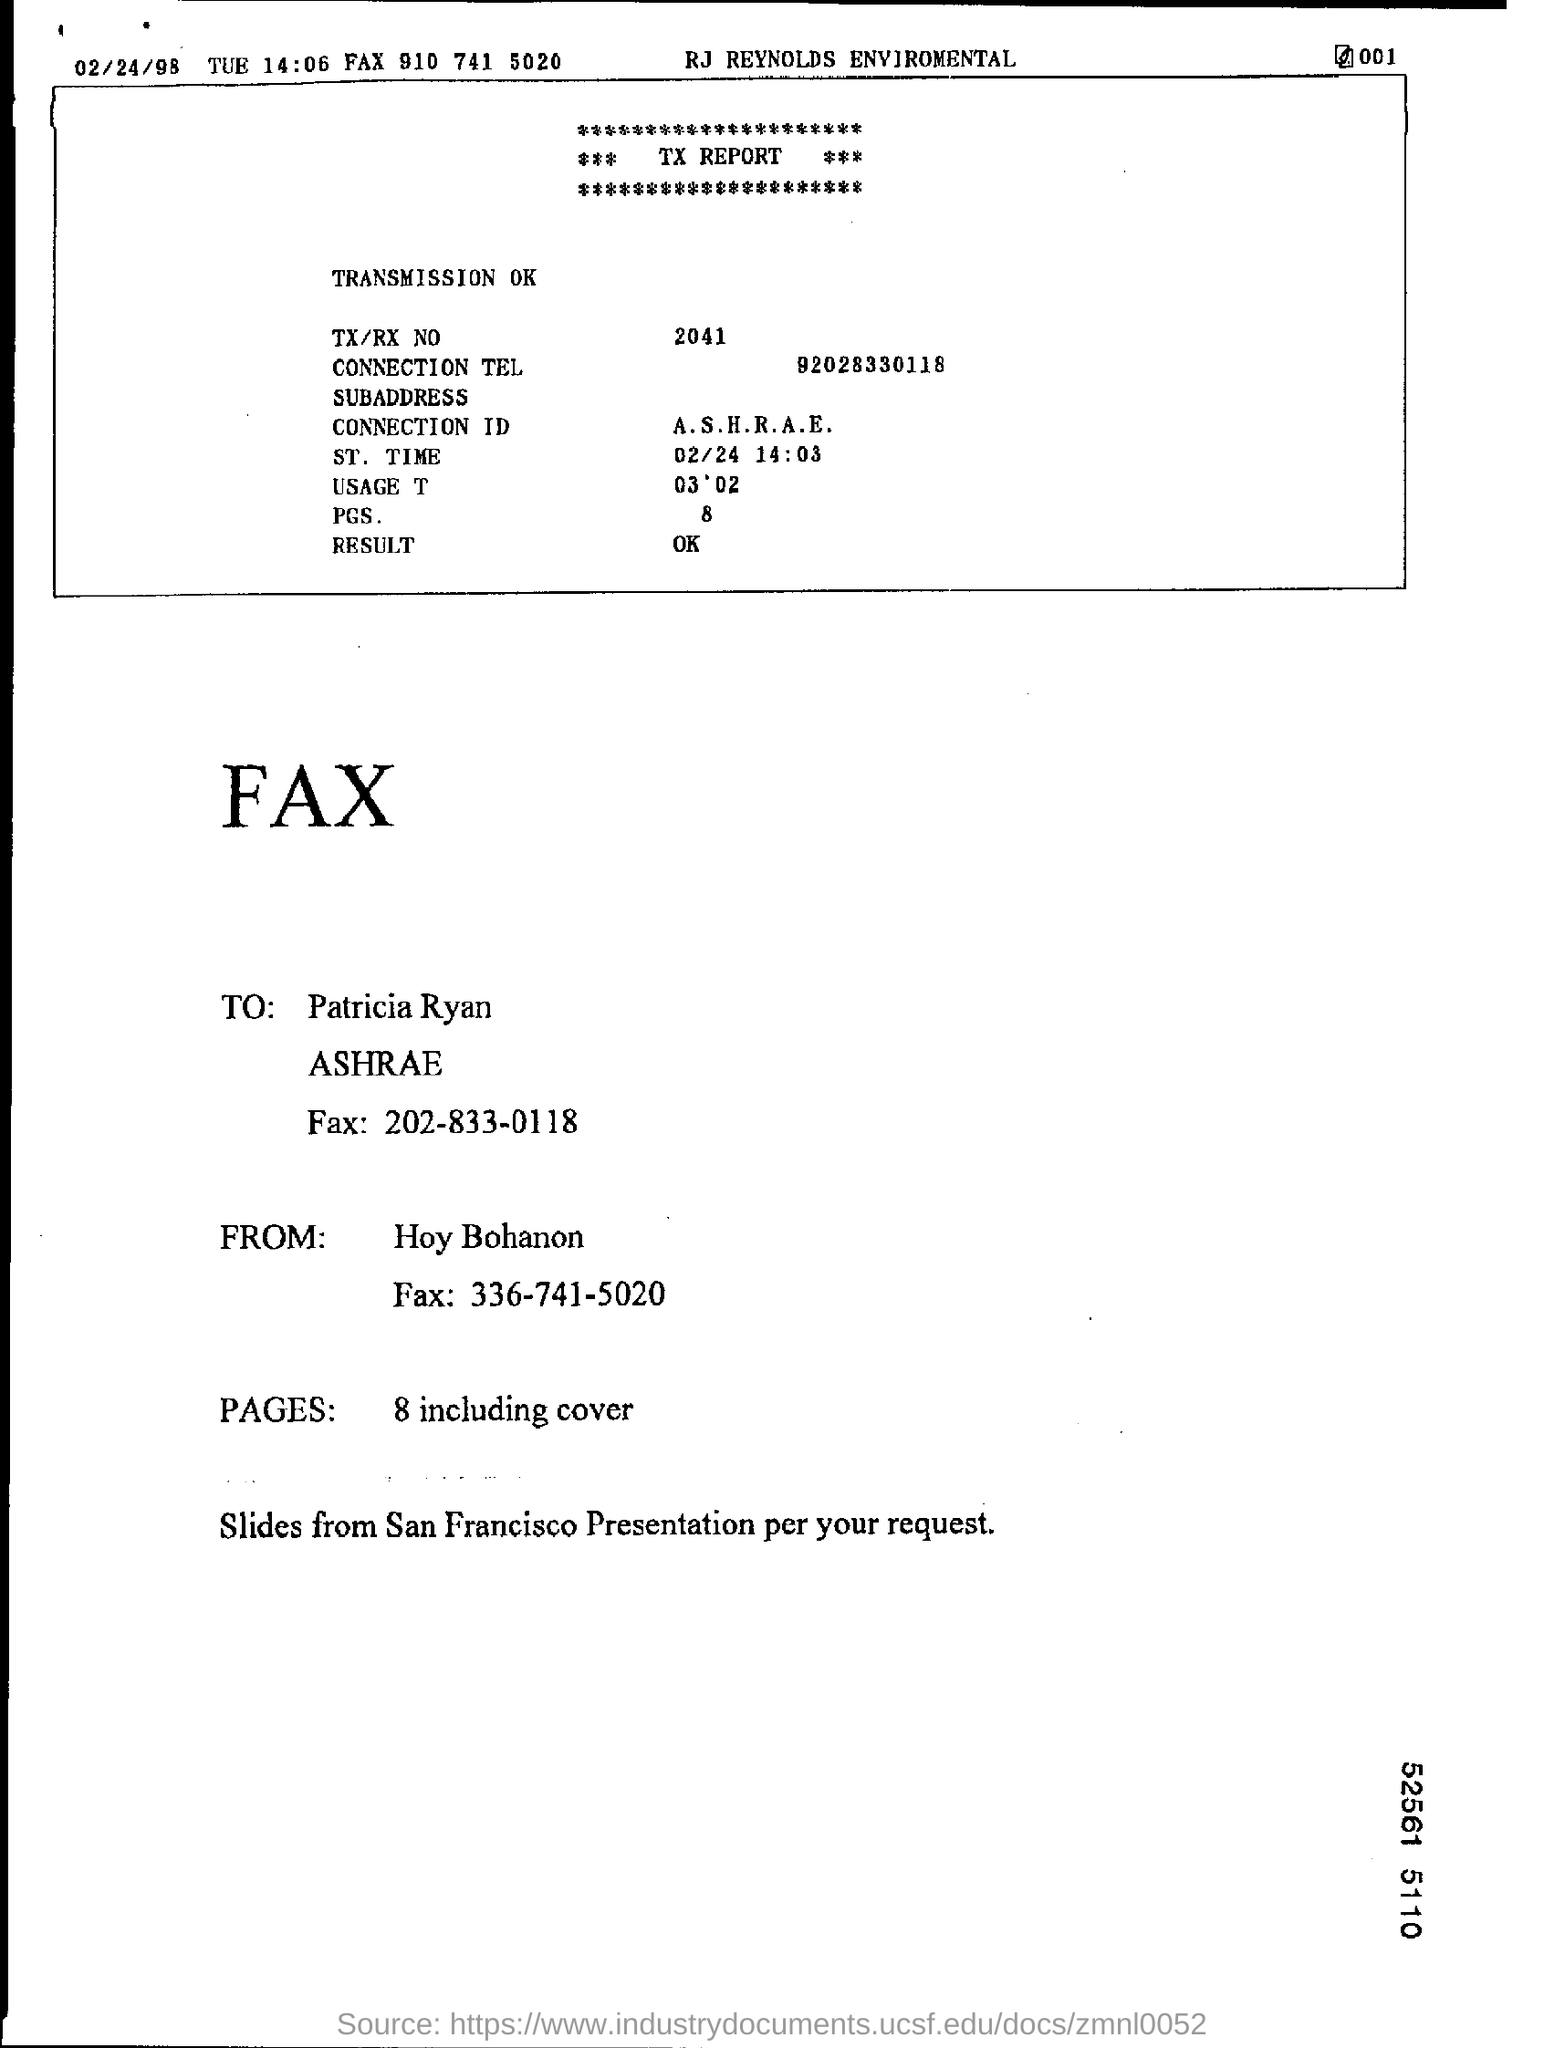Indicate a few pertinent items in this graphic. The fax is addressed to Patricia Ryan. The fax is from Hoy Bohanon. The TX/RX number is 2041. What is the ST time? 02/24 14:03.." is a question asking for information about the ST time, which is a specific time on February 24th, 2023, at 2:03 PM. The telephone number "92028330118" is a connection number. 